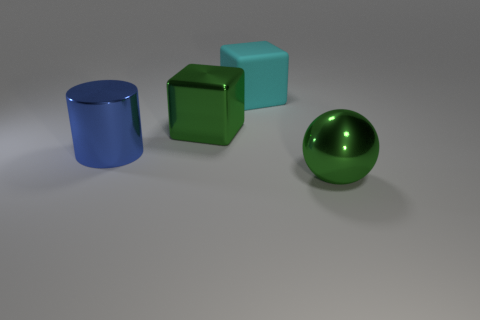The metallic object that is the same color as the shiny block is what shape?
Keep it short and to the point. Sphere. How many cylinders are either matte things or large gray metal objects?
Your answer should be compact. 0. There is a metal sphere that is the same size as the blue metal cylinder; what color is it?
Your answer should be very brief. Green. The thing left of the green shiny object that is left of the large cyan thing is what shape?
Offer a very short reply. Cylinder. What number of other things are the same material as the green block?
Offer a very short reply. 2. How many red things are small rubber cylinders or big metallic balls?
Give a very brief answer. 0. There is a large green metallic sphere; how many metallic spheres are left of it?
Your response must be concise. 0. Is there a large thing that is on the right side of the large green metallic object right of the green thing that is on the left side of the large metallic ball?
Provide a succinct answer. No. Are there more large green matte things than metal things?
Offer a terse response. No. There is a large object right of the large rubber object; what color is it?
Provide a succinct answer. Green. 